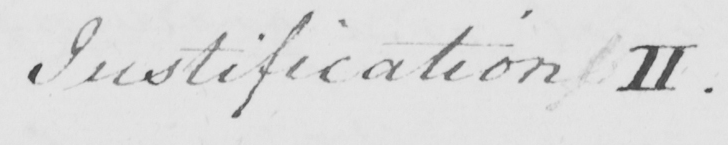Can you read and transcribe this handwriting? Justification II . 